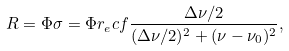Convert formula to latex. <formula><loc_0><loc_0><loc_500><loc_500>R = \Phi \sigma = \Phi r _ { e } c f \frac { \Delta \nu / 2 } { ( \Delta \nu / 2 ) ^ { 2 } + ( \nu - \nu _ { 0 } ) ^ { 2 } } ,</formula> 